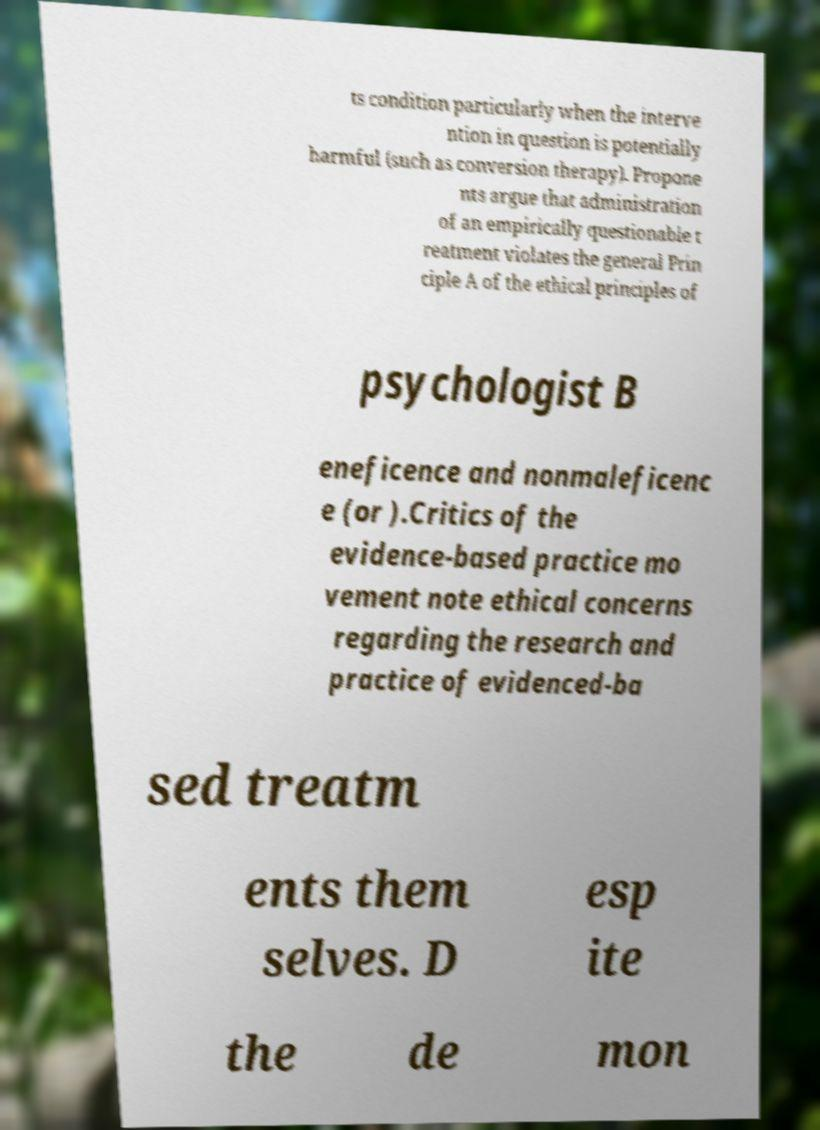Please identify and transcribe the text found in this image. ts condition particularly when the interve ntion in question is potentially harmful (such as conversion therapy). Propone nts argue that administration of an empirically questionable t reatment violates the general Prin ciple A of the ethical principles of psychologist B eneficence and nonmaleficenc e (or ).Critics of the evidence-based practice mo vement note ethical concerns regarding the research and practice of evidenced-ba sed treatm ents them selves. D esp ite the de mon 